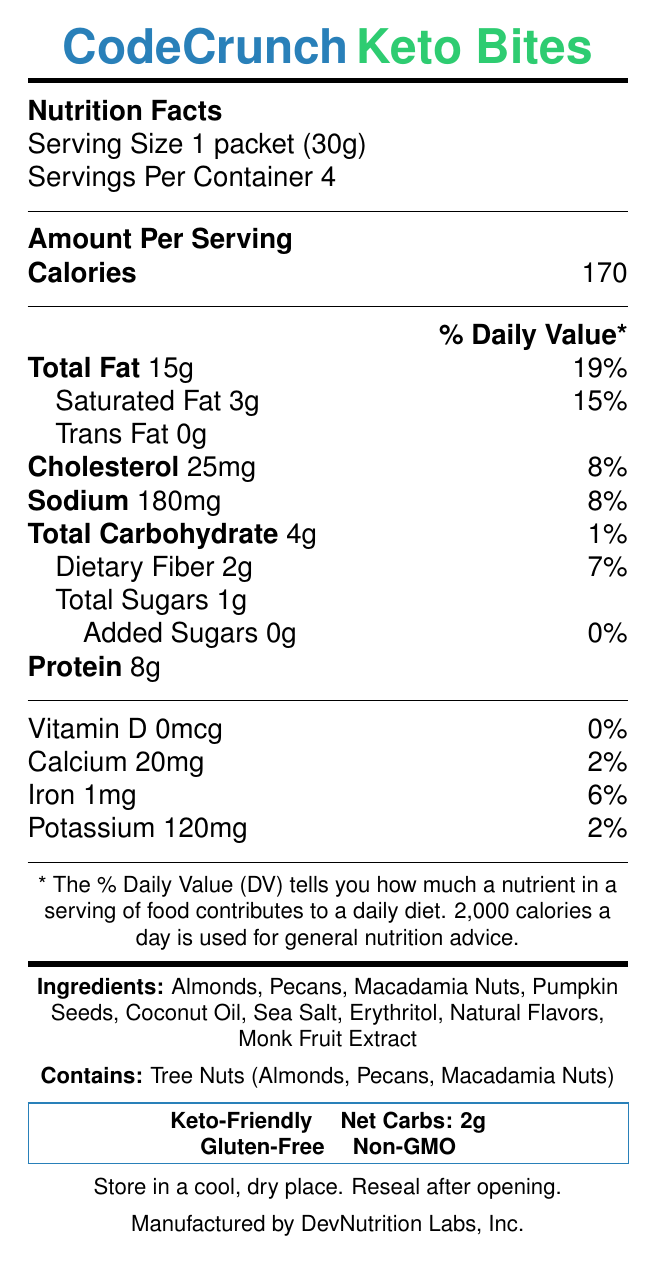What is the serving size of CodeCrunch Keto Bites? The serving size is stated at the beginning of the Nutrition Facts section.
Answer: 1 packet (30g) How many servings are there per container? This information is listed right under the serving size.
Answer: 4 How many calories are in one serving? The amount per serving section lists the number of calories.
Answer: 170 How much total fat is in one serving? The document states the total fat content per serving is 15g.
Answer: 15g What percentage of the daily value for cholesterol does one serving of CodeCrunch Keto Bites provide? The daily value percentage for cholesterol is listed next to its amount.
Answer: 8% List three of the first ingredients in CodeCrunch Keto Bites. These are the first three ingredients listed in the document.
Answer: Almonds, Pecans, Macadamia Nuts Does the product contain any artificial sweeteners? It is mentioned in the document that there are no artificial sweeteners.
Answer: No Is this product considered vegan? The document specifies that the product is not vegan.
Answer: No Which of the following allergens are present in CodeCrunch Keto Bites? A. Gluten B. Dairy C. Tree Nuts D. Soy The allergen information states that the product contains tree nuts.
Answer: C. Tree Nuts What is the amount of dietary fiber in one serving? The document lists 2g of dietary fiber per serving.
Answer: 2g Is this product gluten-free? The document explicitly states that the product is gluten-free.
Answer: Yes What is the net carb content of CodeCrunch Keto Bites? The bottom section of the document highlights the net carb content.
Answer: 2g Which company manufactures CodeCrunch Keto Bites? The manufacturer's name is listed at the end of the document.
Answer: DevNutrition Labs, Inc. What is the percentage of daily value for sodium in one serving? The daily value percentage for sodium is listed in the Nutrition Facts.
Answer: 8% Summarize the main idea of the document. The summary captures the key information about the product’s purpose, nutritional benefits, and ingredients, reflecting the main points in the document.
Answer: CodeCrunch Keto Bites is a keto-friendly, low-carb snack designed for late-night coding sessions. It is high in healthy fats and low in carbs, suitable for maintaining ketosis and energy levels. The product contains natural ingredients, avoids artificial sweeteners, and is free from gluten and GMOs. What is the recommended storage condition for CodeCrunch Keto Bites? The storage instructions are clearly stated towards the end of the document.
Answer: Store in a cool, dry place. Reseal after opening. What is the caffeine content of CodeCrunch Keto Bites? The document specifies that the product contains 0mg of caffeine.
Answer: 0mg How much iron does one serving of CodeCrunch Keto Bites provide? The iron content per serving is listed near the bottom of the Nutrition Facts.
Answer: 1mg Does the document provide information about who created the nutritional label? The document does not specify who created the nutritional label, just the manufacturer.
Answer: Not enough information 